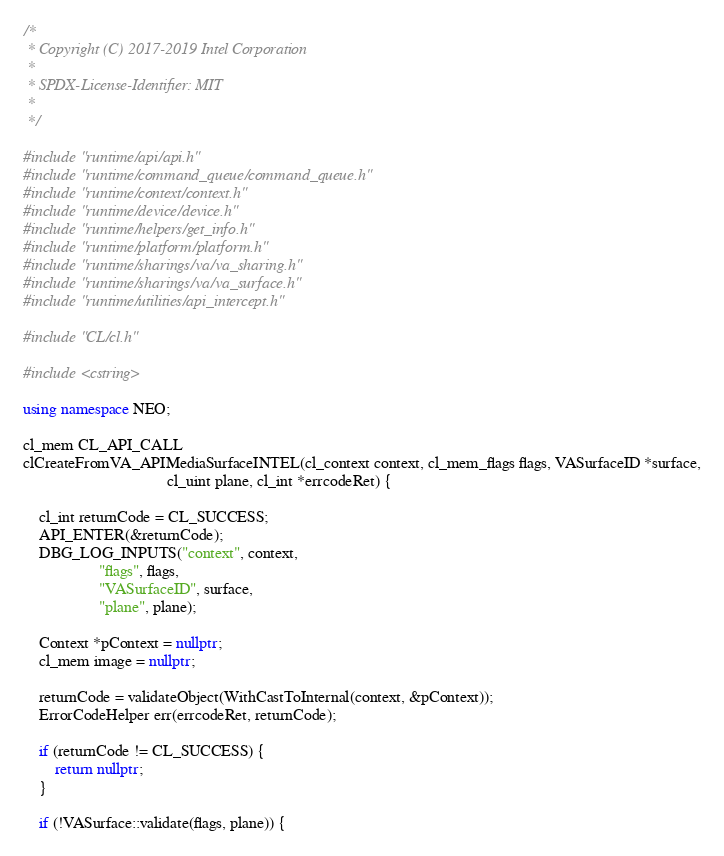Convert code to text. <code><loc_0><loc_0><loc_500><loc_500><_C++_>/*
 * Copyright (C) 2017-2019 Intel Corporation
 *
 * SPDX-License-Identifier: MIT
 *
 */

#include "runtime/api/api.h"
#include "runtime/command_queue/command_queue.h"
#include "runtime/context/context.h"
#include "runtime/device/device.h"
#include "runtime/helpers/get_info.h"
#include "runtime/platform/platform.h"
#include "runtime/sharings/va/va_sharing.h"
#include "runtime/sharings/va/va_surface.h"
#include "runtime/utilities/api_intercept.h"

#include "CL/cl.h"

#include <cstring>

using namespace NEO;

cl_mem CL_API_CALL
clCreateFromVA_APIMediaSurfaceINTEL(cl_context context, cl_mem_flags flags, VASurfaceID *surface,
                                    cl_uint plane, cl_int *errcodeRet) {

    cl_int returnCode = CL_SUCCESS;
    API_ENTER(&returnCode);
    DBG_LOG_INPUTS("context", context,
                   "flags", flags,
                   "VASurfaceID", surface,
                   "plane", plane);

    Context *pContext = nullptr;
    cl_mem image = nullptr;

    returnCode = validateObject(WithCastToInternal(context, &pContext));
    ErrorCodeHelper err(errcodeRet, returnCode);

    if (returnCode != CL_SUCCESS) {
        return nullptr;
    }

    if (!VASurface::validate(flags, plane)) {</code> 